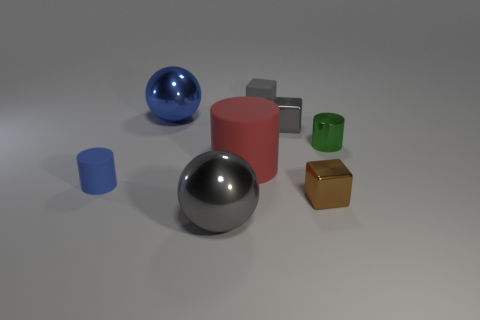How many green things are either large cylinders or big metal objects? In the image, there is one green object that appears to be a small cylinder. There are no green large cylinders or big metal objects, so the count for green things that are large cylinders or big metal objects is zero. 